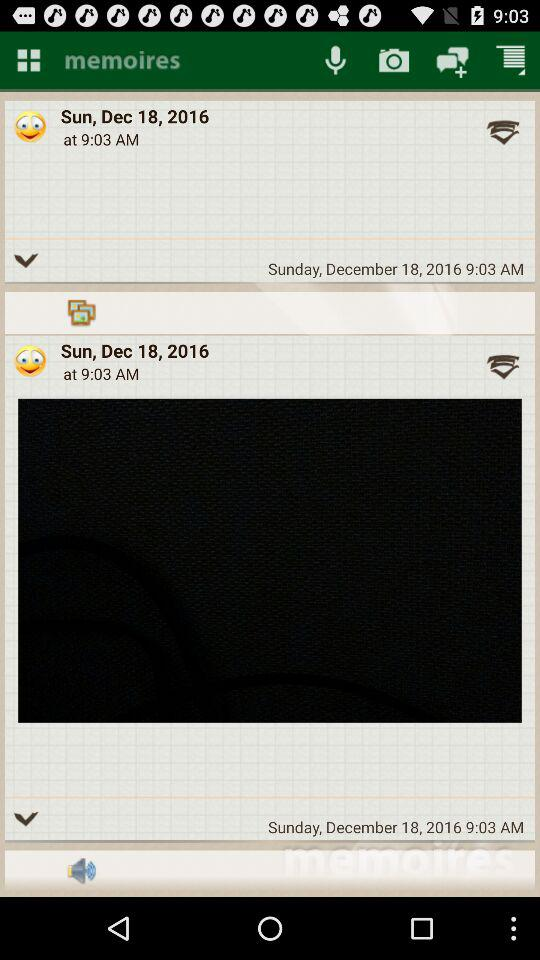What day falls on December 18, 2016? The day is Sunday. 